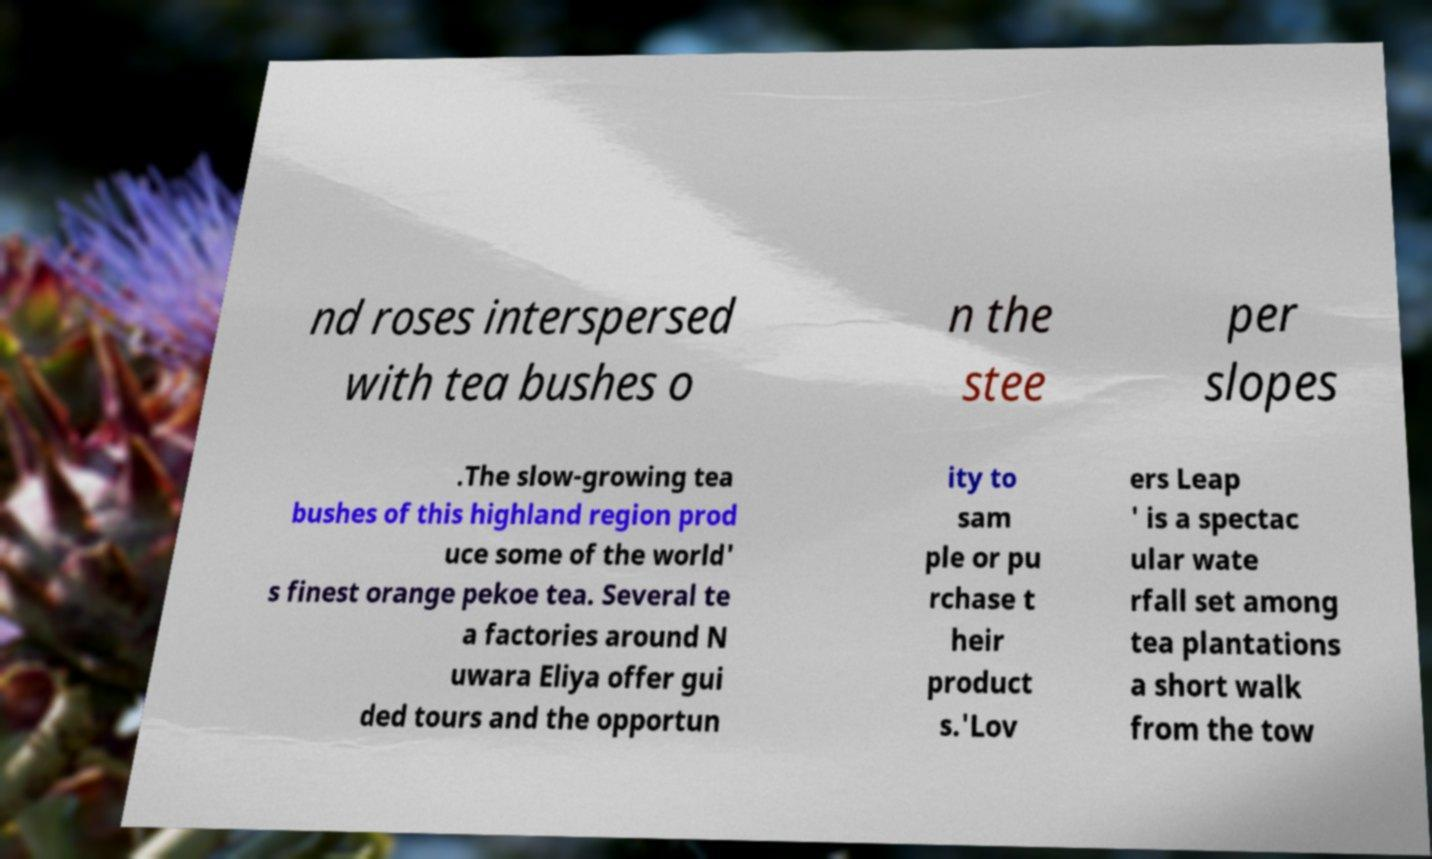Can you accurately transcribe the text from the provided image for me? nd roses interspersed with tea bushes o n the stee per slopes .The slow-growing tea bushes of this highland region prod uce some of the world' s finest orange pekoe tea. Several te a factories around N uwara Eliya offer gui ded tours and the opportun ity to sam ple or pu rchase t heir product s.'Lov ers Leap ' is a spectac ular wate rfall set among tea plantations a short walk from the tow 